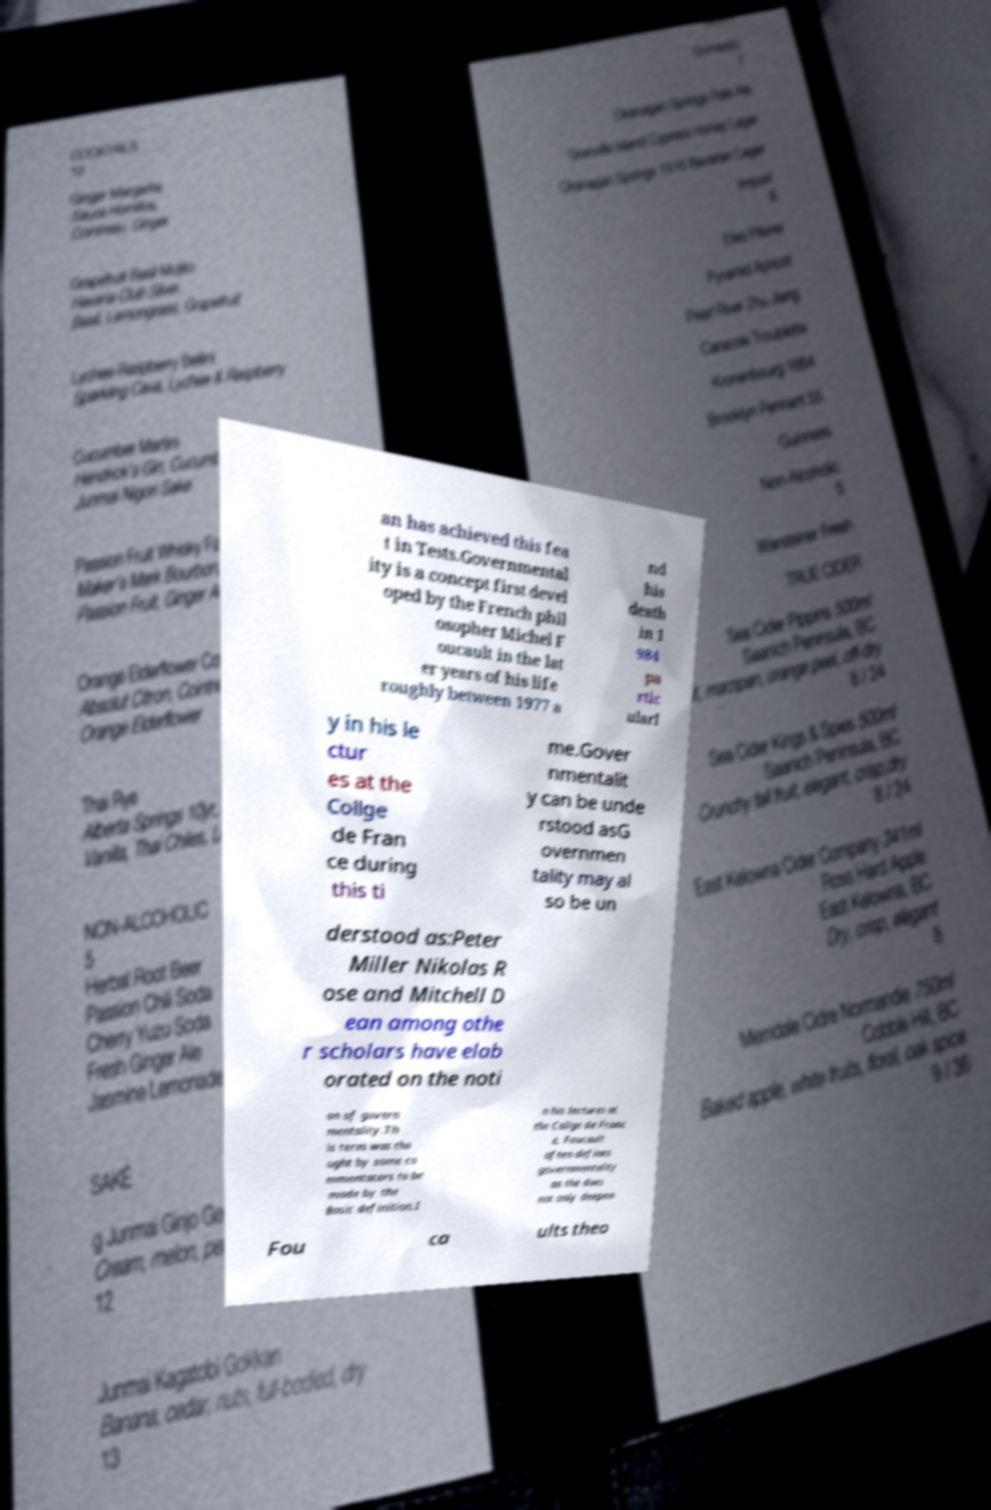Please read and relay the text visible in this image. What does it say? an has achieved this fea t in Tests.Governmental ity is a concept first devel oped by the French phil osopher Michel F oucault in the lat er years of his life roughly between 1977 a nd his death in 1 984 pa rtic ularl y in his le ctur es at the Collge de Fran ce during this ti me.Gover nmentalit y can be unde rstood asG overnmen tality may al so be un derstood as:Peter Miller Nikolas R ose and Mitchell D ean among othe r scholars have elab orated on the noti on of govern mentality.Th is term was tho ught by some co mmentators to be made by the Basic definition.I n his lectures at the Collge de Franc e, Foucault often defines governmentality as the does not only deepen Fou ca ults theo 